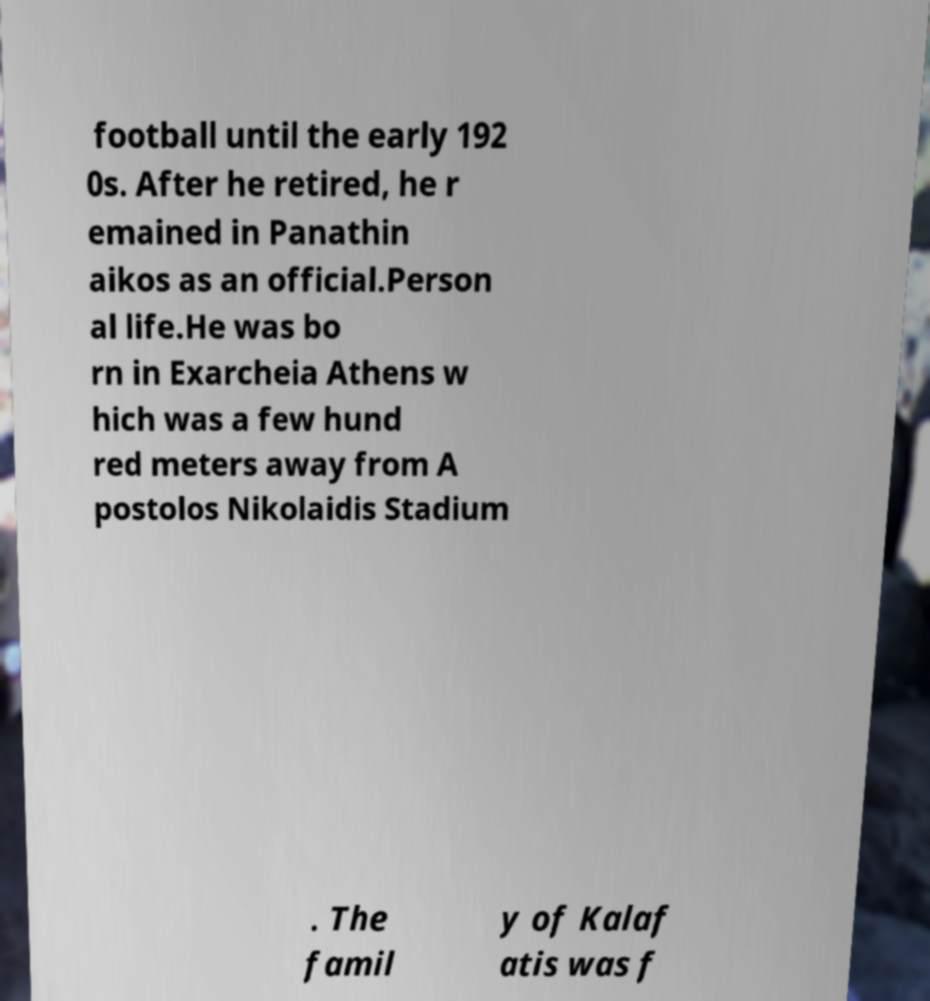For documentation purposes, I need the text within this image transcribed. Could you provide that? football until the early 192 0s. After he retired, he r emained in Panathin aikos as an official.Person al life.He was bo rn in Exarcheia Athens w hich was a few hund red meters away from A postolos Nikolaidis Stadium . The famil y of Kalaf atis was f 